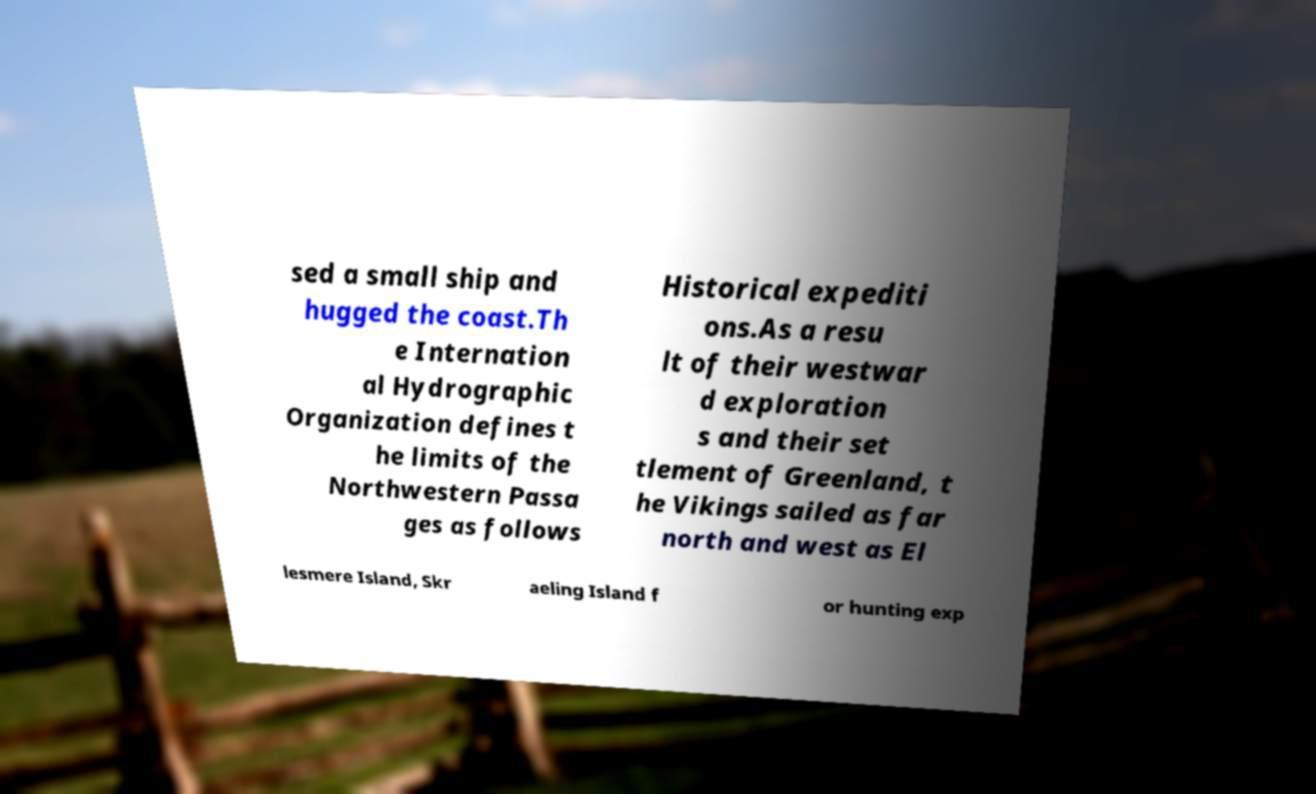What messages or text are displayed in this image? I need them in a readable, typed format. sed a small ship and hugged the coast.Th e Internation al Hydrographic Organization defines t he limits of the Northwestern Passa ges as follows Historical expediti ons.As a resu lt of their westwar d exploration s and their set tlement of Greenland, t he Vikings sailed as far north and west as El lesmere Island, Skr aeling Island f or hunting exp 